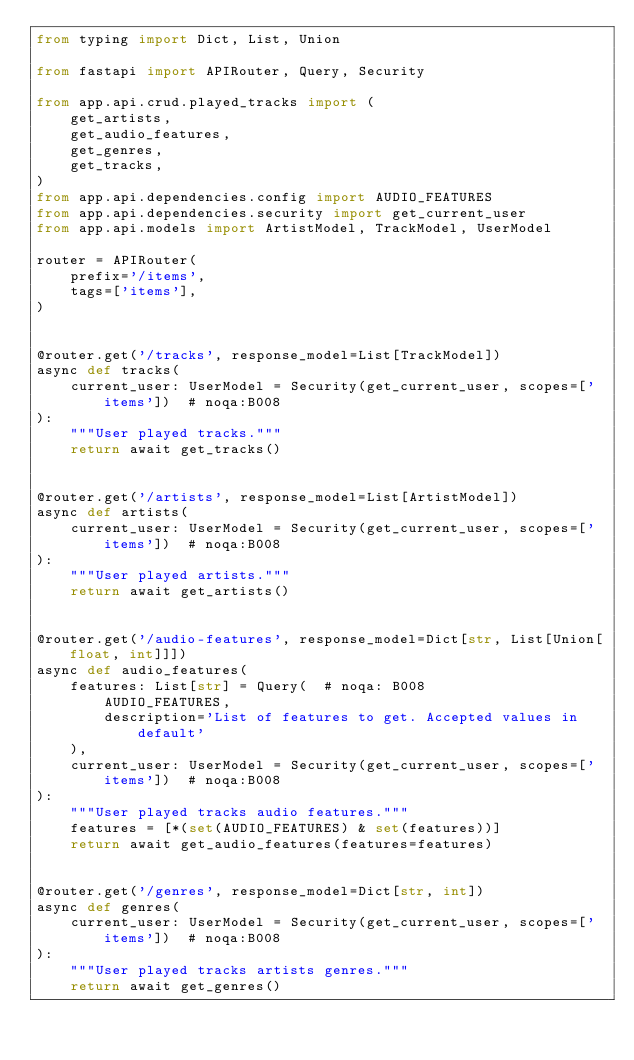<code> <loc_0><loc_0><loc_500><loc_500><_Python_>from typing import Dict, List, Union

from fastapi import APIRouter, Query, Security

from app.api.crud.played_tracks import (
    get_artists,
    get_audio_features,
    get_genres,
    get_tracks,
)
from app.api.dependencies.config import AUDIO_FEATURES
from app.api.dependencies.security import get_current_user
from app.api.models import ArtistModel, TrackModel, UserModel

router = APIRouter(
    prefix='/items',
    tags=['items'],
)


@router.get('/tracks', response_model=List[TrackModel])
async def tracks(
    current_user: UserModel = Security(get_current_user, scopes=['items'])  # noqa:B008
):
    """User played tracks."""
    return await get_tracks()


@router.get('/artists', response_model=List[ArtistModel])
async def artists(
    current_user: UserModel = Security(get_current_user, scopes=['items'])  # noqa:B008
):
    """User played artists."""
    return await get_artists()


@router.get('/audio-features', response_model=Dict[str, List[Union[float, int]]])
async def audio_features(
    features: List[str] = Query(  # noqa: B008
        AUDIO_FEATURES,
        description='List of features to get. Accepted values in default'
    ),
    current_user: UserModel = Security(get_current_user, scopes=['items'])  # noqa:B008
):
    """User played tracks audio features."""
    features = [*(set(AUDIO_FEATURES) & set(features))]
    return await get_audio_features(features=features)


@router.get('/genres', response_model=Dict[str, int])
async def genres(
    current_user: UserModel = Security(get_current_user, scopes=['items'])  # noqa:B008
):
    """User played tracks artists genres."""
    return await get_genres()
</code> 